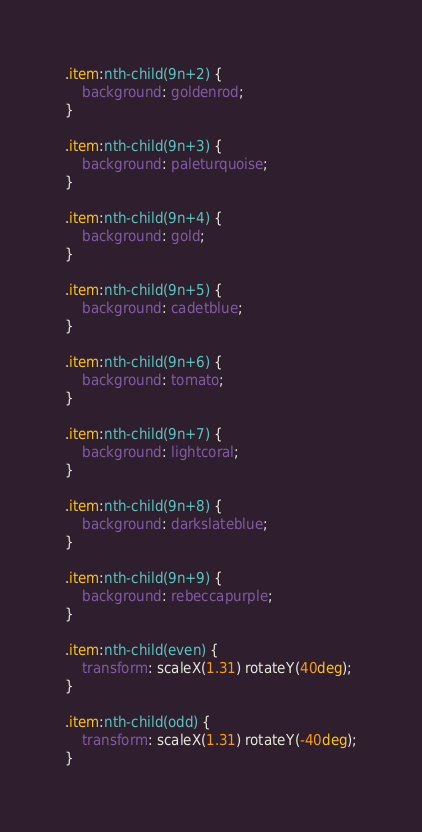<code> <loc_0><loc_0><loc_500><loc_500><_CSS_>
.item:nth-child(9n+2) {
    background: goldenrod;
}

.item:nth-child(9n+3) {
    background: paleturquoise;
}

.item:nth-child(9n+4) {
    background: gold;
}

.item:nth-child(9n+5) {
    background: cadetblue;
}

.item:nth-child(9n+6) {
    background: tomato;
}

.item:nth-child(9n+7) {
    background: lightcoral;
}

.item:nth-child(9n+8) {
    background: darkslateblue;
}

.item:nth-child(9n+9) {
    background: rebeccapurple;
}

.item:nth-child(even) {
    transform: scaleX(1.31) rotateY(40deg);
}

.item:nth-child(odd) {
    transform: scaleX(1.31) rotateY(-40deg);
}
</code> 